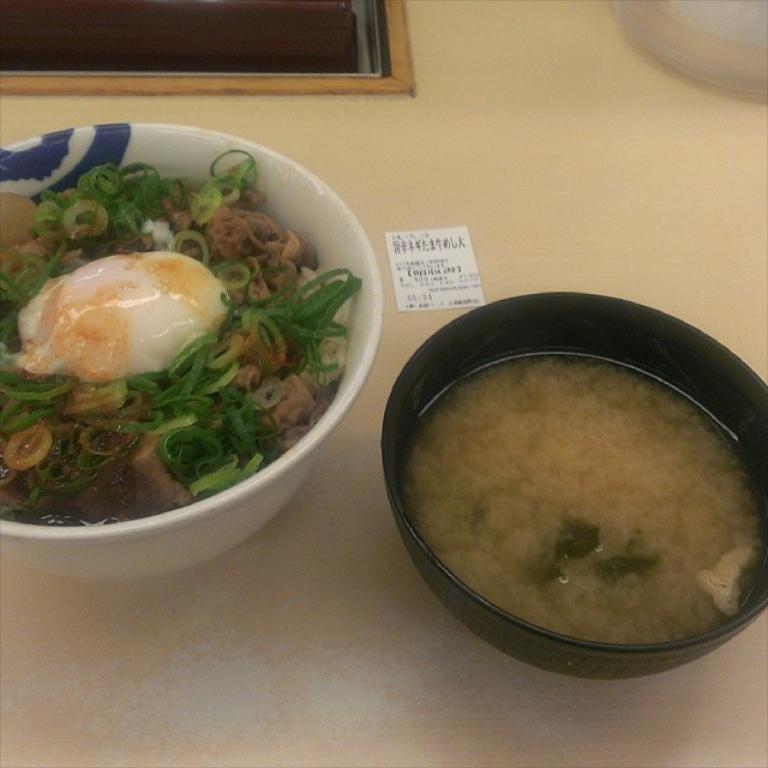Describe this image in one or two sentences. In the foreground of the picture there is a table, on the table there are bowls. In the bowels there are food items. 